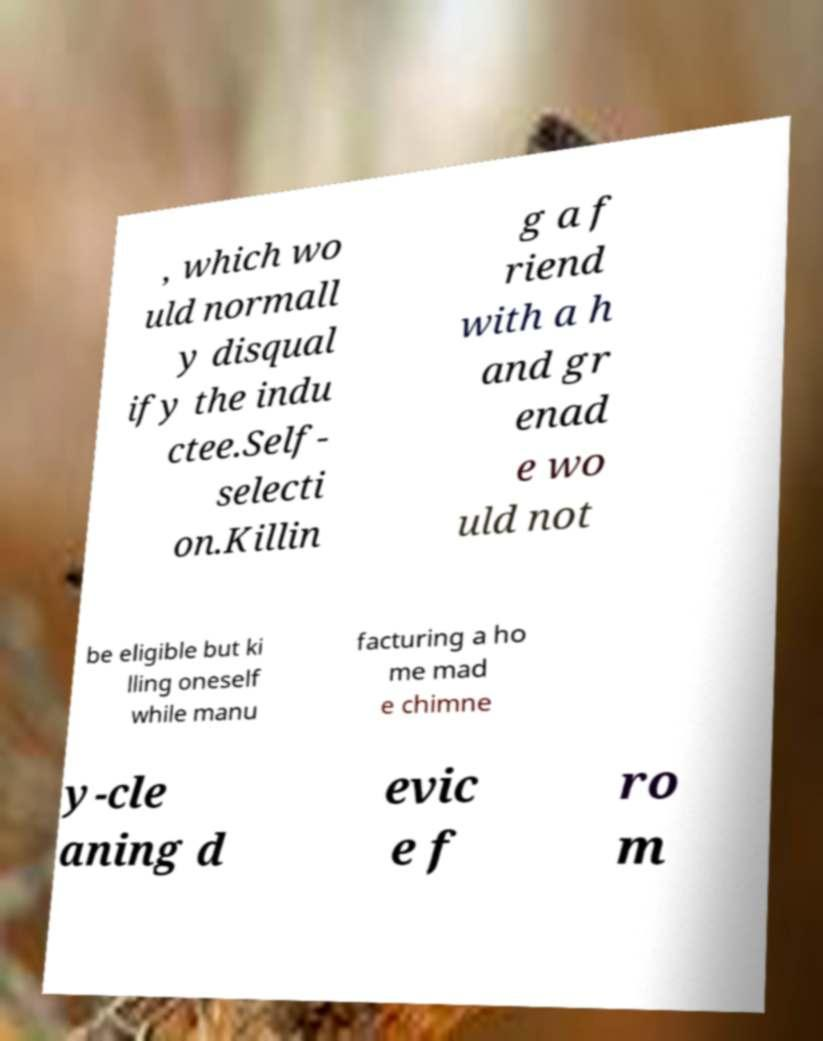Please read and relay the text visible in this image. What does it say? , which wo uld normall y disqual ify the indu ctee.Self- selecti on.Killin g a f riend with a h and gr enad e wo uld not be eligible but ki lling oneself while manu facturing a ho me mad e chimne y-cle aning d evic e f ro m 